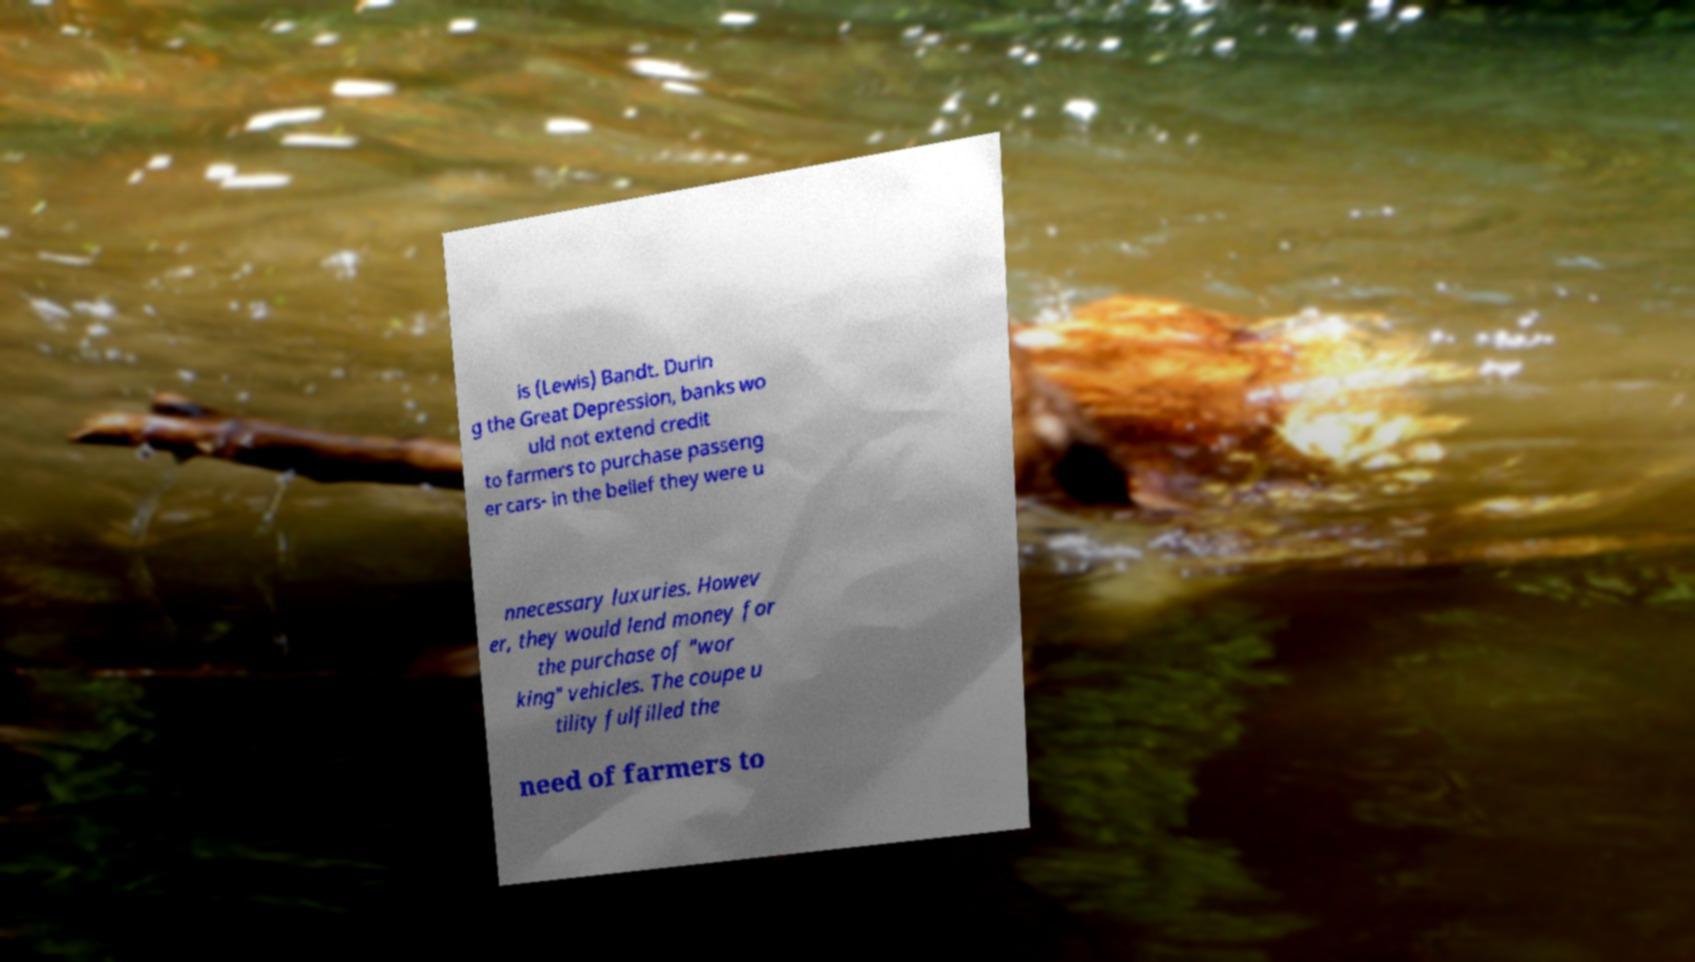Can you read and provide the text displayed in the image?This photo seems to have some interesting text. Can you extract and type it out for me? is (Lewis) Bandt. Durin g the Great Depression, banks wo uld not extend credit to farmers to purchase passeng er cars- in the belief they were u nnecessary luxuries. Howev er, they would lend money for the purchase of "wor king" vehicles. The coupe u tility fulfilled the need of farmers to 